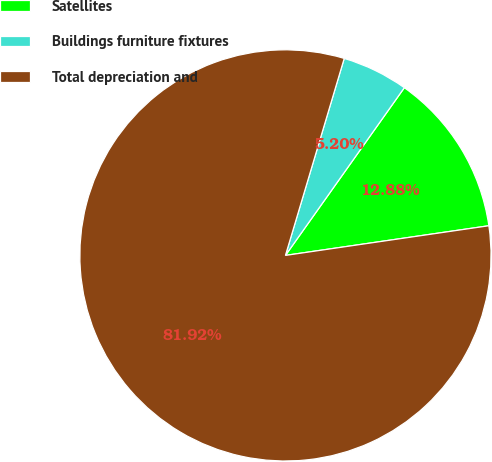Convert chart. <chart><loc_0><loc_0><loc_500><loc_500><pie_chart><fcel>Satellites<fcel>Buildings furniture fixtures<fcel>Total depreciation and<nl><fcel>12.88%<fcel>5.2%<fcel>81.92%<nl></chart> 